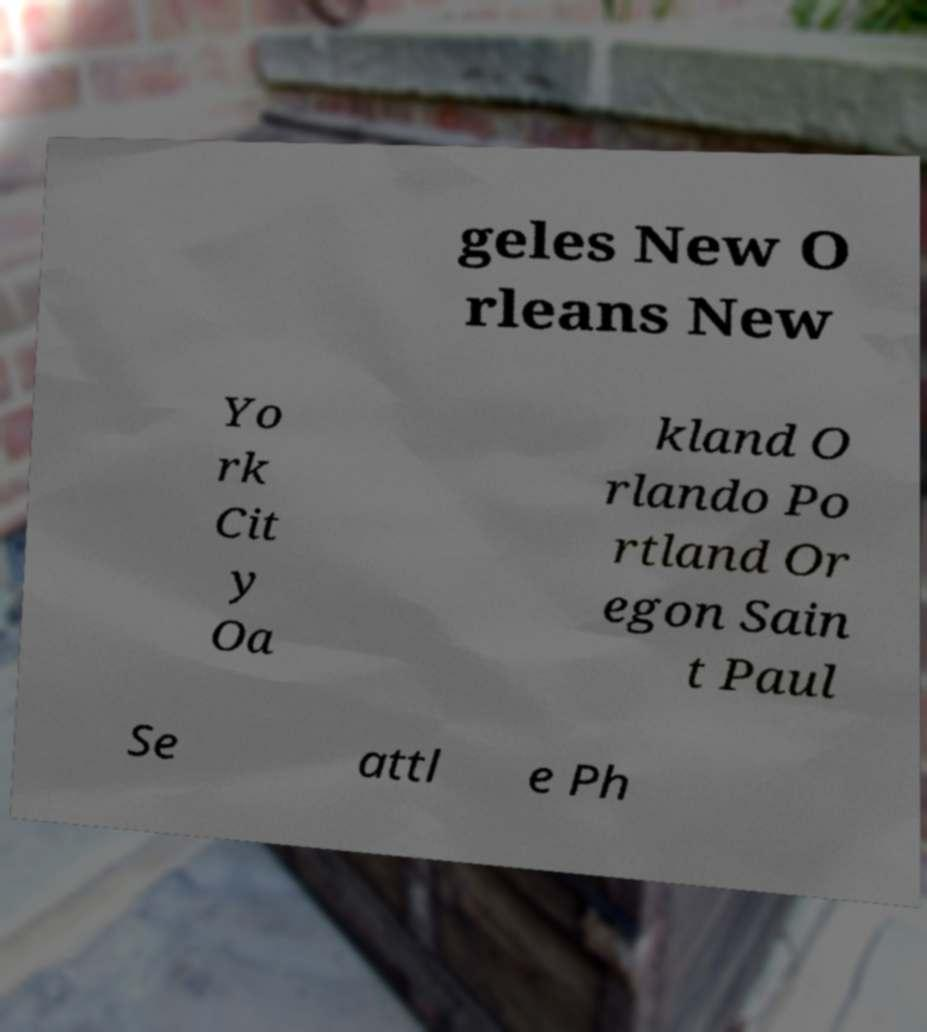Can you read and provide the text displayed in the image?This photo seems to have some interesting text. Can you extract and type it out for me? geles New O rleans New Yo rk Cit y Oa kland O rlando Po rtland Or egon Sain t Paul Se attl e Ph 